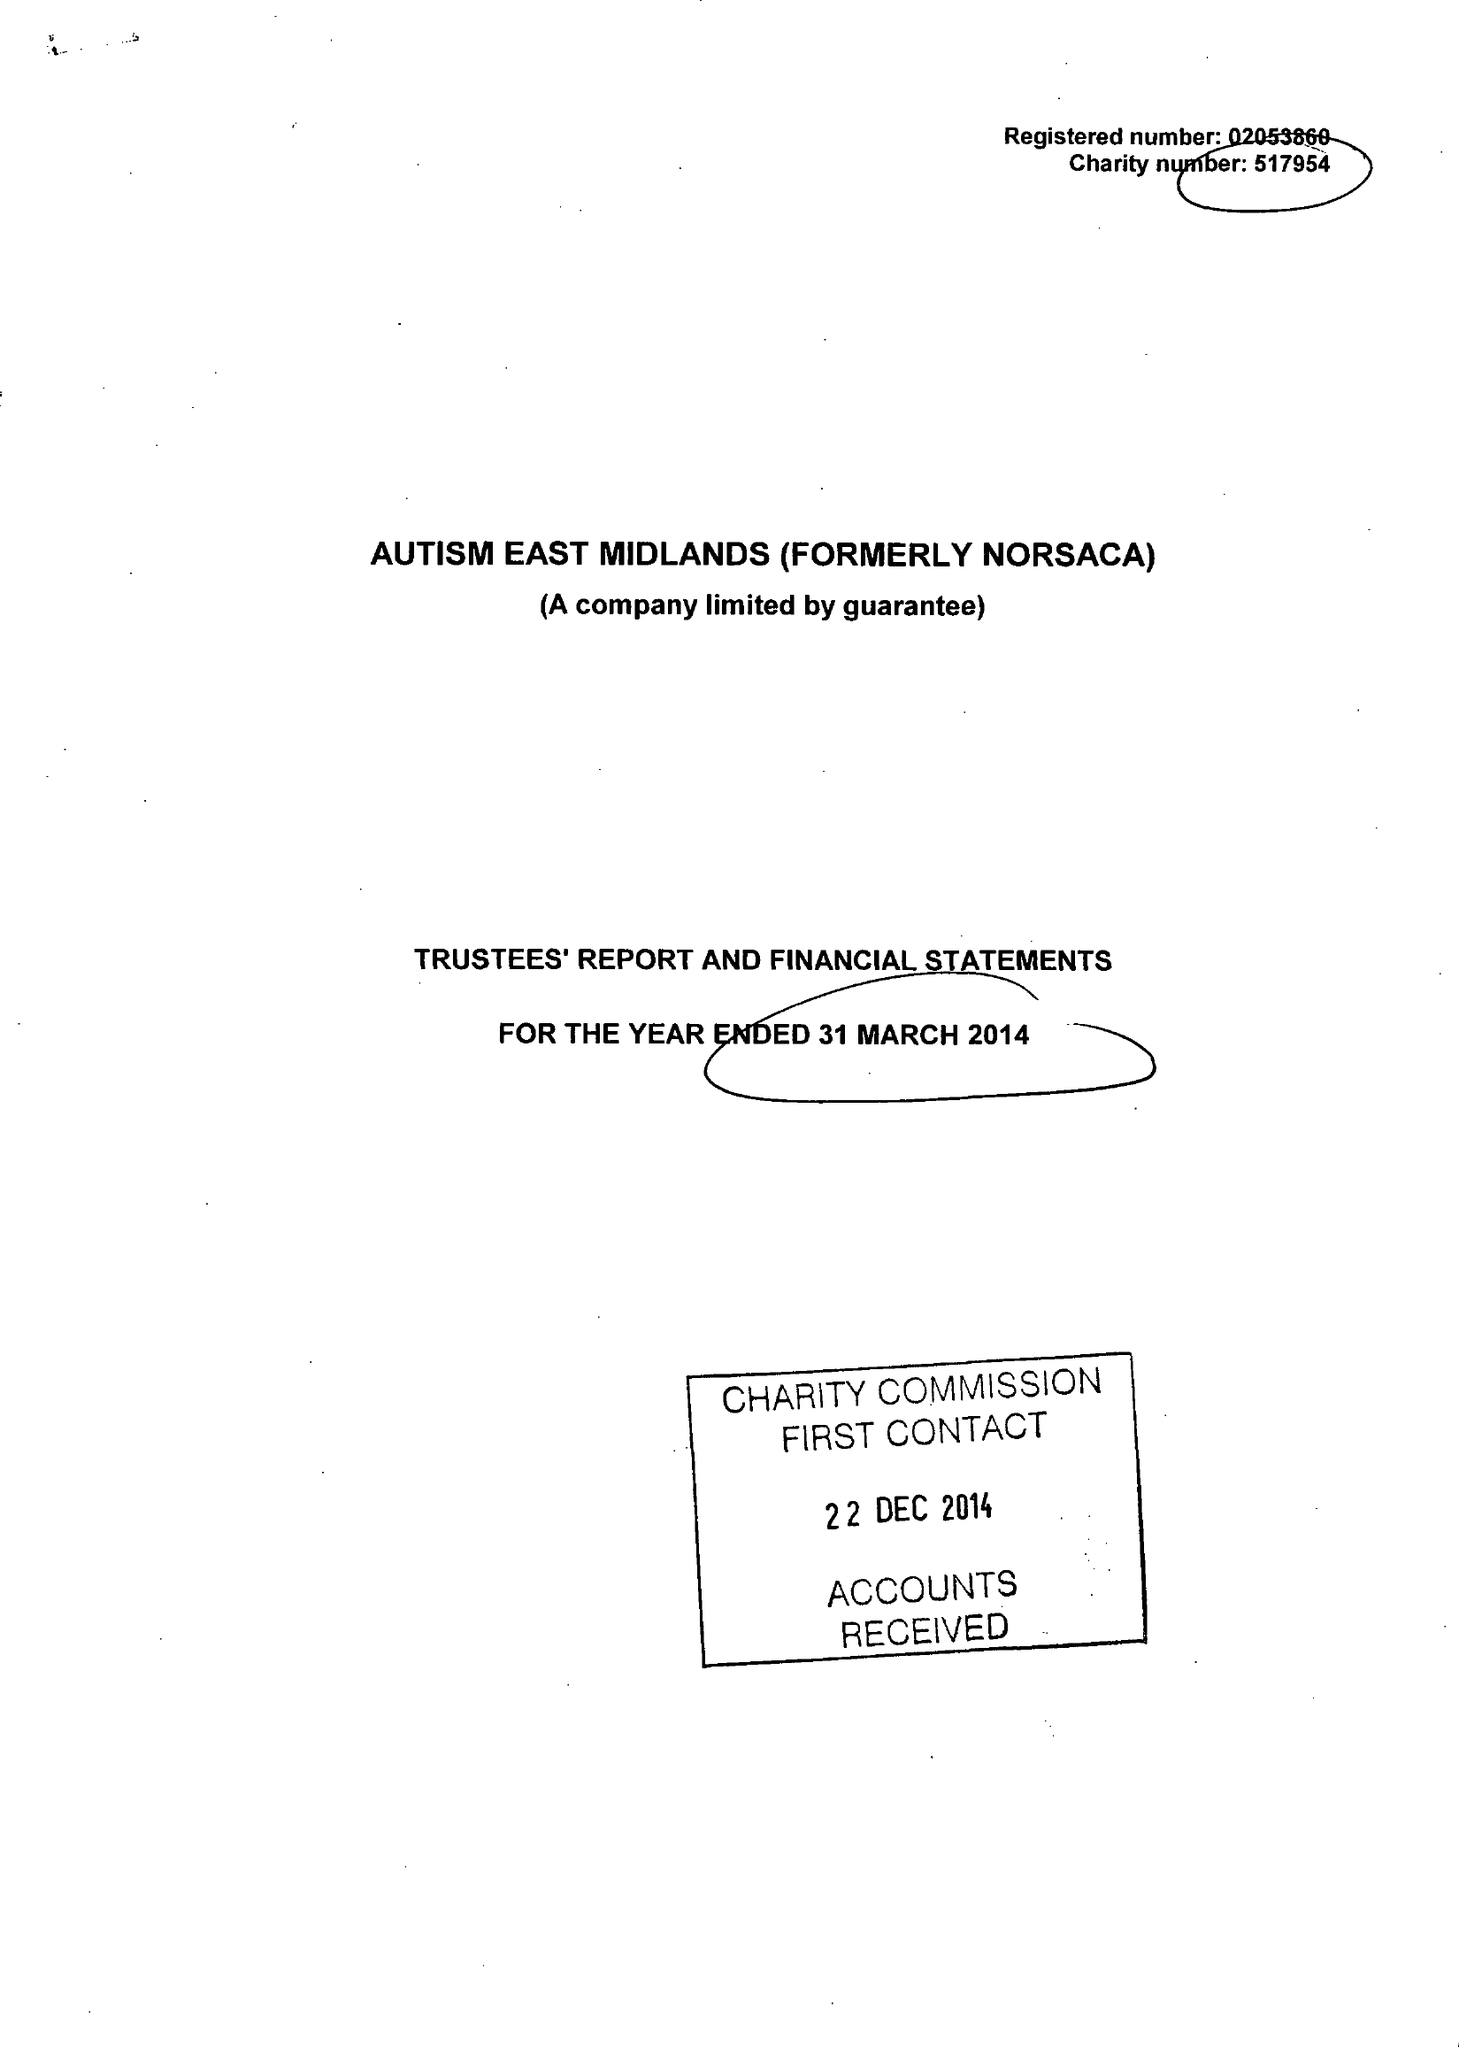What is the value for the address__street_line?
Answer the question using a single word or phrase. MORVEN STREET 